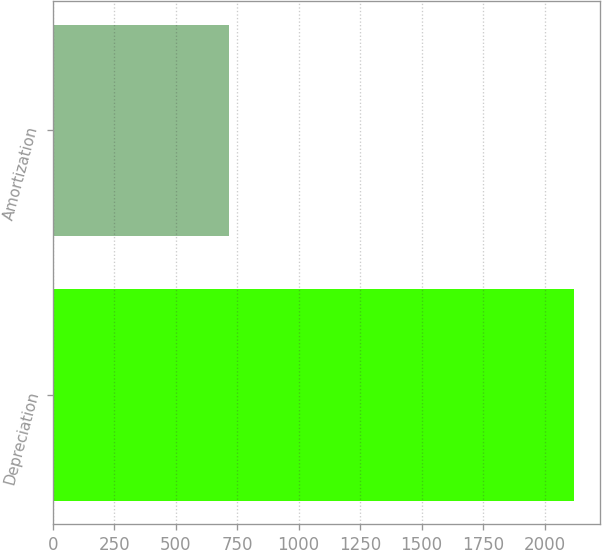Convert chart. <chart><loc_0><loc_0><loc_500><loc_500><bar_chart><fcel>Depreciation<fcel>Amortization<nl><fcel>2119<fcel>718<nl></chart> 